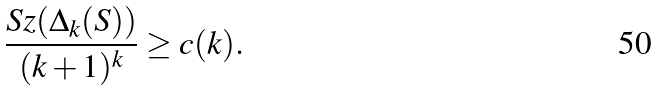Convert formula to latex. <formula><loc_0><loc_0><loc_500><loc_500>\frac { S z ( \Delta _ { k } ( S ) ) } { ( k + 1 ) ^ { k } } \geq c ( k ) .</formula> 